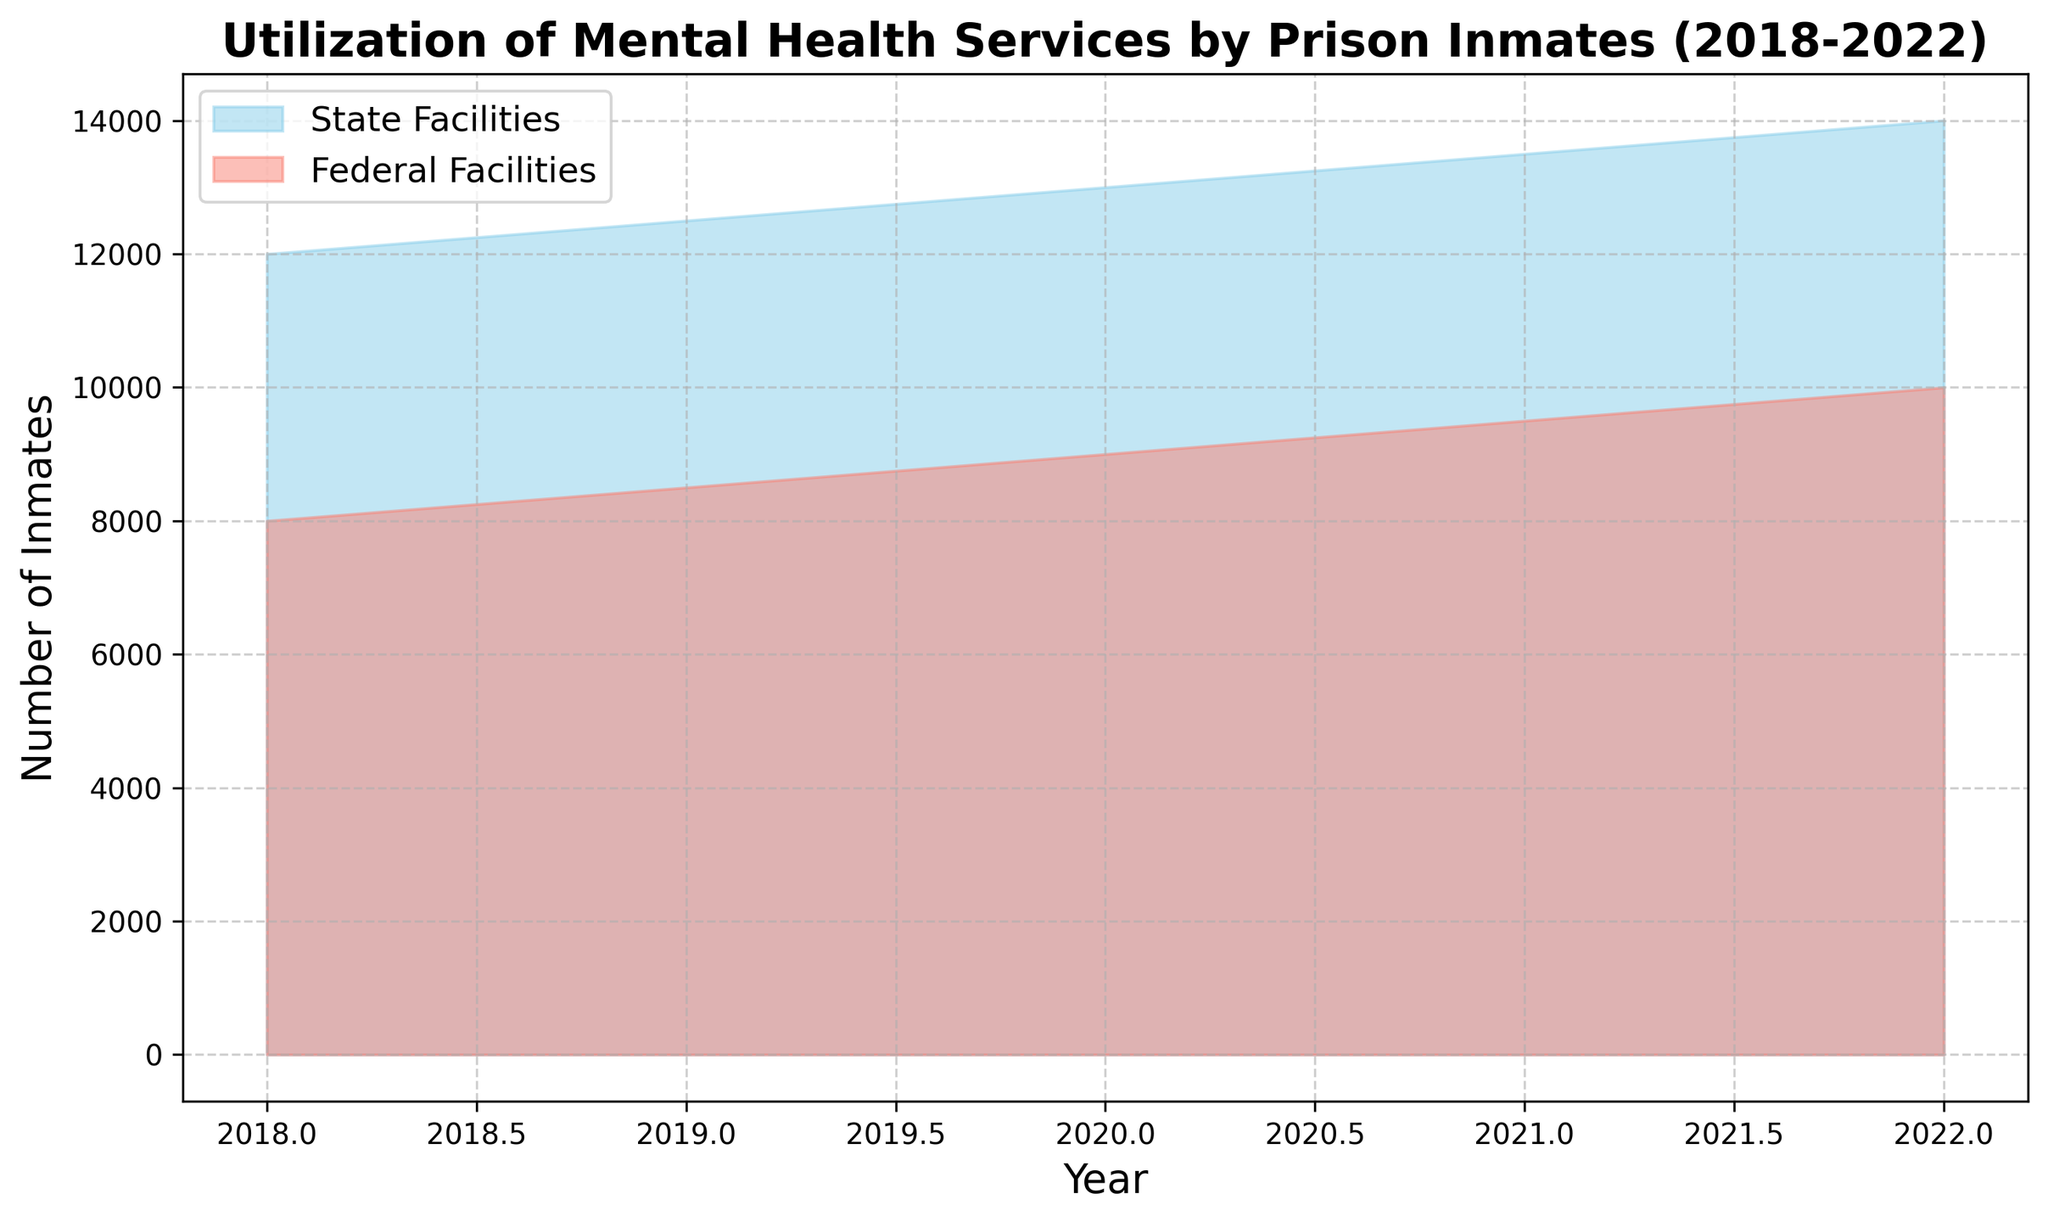What is the difference in the number of inmates utilizing mental health services between state and federal facilities in 2018? From the figure, find the number of inmates utilizing mental health services in state and federal facilities in 2018. The difference is 12000 (State) - 8000 (Federal).
Answer: 4000 Which facility type saw a greater increase in the utilization of mental health services from 2019 to 2020? Examine the chart to compare the increase in the number of inmates utilizing mental health services between 2019 and 2020 for both state and federal facilities. State facilities increased from 12500 to 13000 (500), and federal facilities increased from 8500 to 9000 (500).
Answer: Both increased equally In which year did state facilities have the highest number of inmates utilizing mental health services? Look at the chart to identify the peak value for state facilities across the years displayed. State facilities had the highest number in 2022 with 14000 inmates using mental health services.
Answer: 2022 Is the trend of the utilization of mental health services increasing or decreasing for both facility types over the years? Observe the trajectory of the areas filled in the chart for both state and federal facilities from 2018 to 2022. Both show a generally increasing trend over the years.
Answer: Increasing What is the total number of inmates utilizing mental health services in both state and federal facilities combined in 2020? Find the values for state and federal facilities in 2020 and add them together: 13000 (State) + 9000 (Federal).
Answer: 22000 Which facility type had a steeper increase in the utilization of mental health services from 2018 to 2022? Evaluate the overall increase for both facility types from 2018 to 2022: State facilities increased from 12000 to 14000 (2000), and federal facilities increased from 8000 to 10000 (2000). Both facility types had an equal increase over this period.
Answer: Both increased equally What is the average number of inmates utilizing mental health services in federal facilities over the five years? Calculate the average by summing the values for federal facilities from 2018 to 2022 and dividing by the number of years: (8000 + 8500 + 9000 + 9500 + 10000) / 5 = 45000 / 5.
Answer: 9000 How does the visual representation of the areas filled between state and federal facilities help in understanding the utilization differences? The state facilities are shown in sky blue and federal facilities in salmon. The filled areas for state facilities are typically larger, indicating more inmates utilized mental health services in state facilities at all times.
Answer: The filled areas easily show state facilities have more usage 